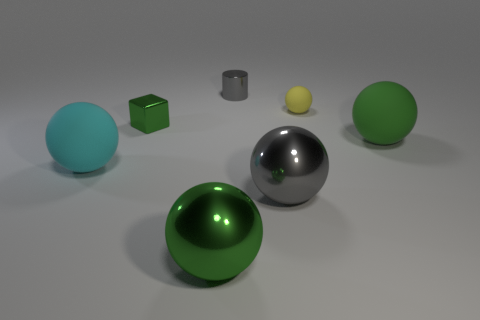Are there fewer cyan matte spheres that are behind the small green object than tiny green metal cubes that are behind the small gray cylinder?
Provide a short and direct response. No. What is the color of the tiny block?
Your response must be concise. Green. What number of metallic objects have the same color as the tiny cylinder?
Offer a very short reply. 1. Are there any gray shiny balls behind the green metal block?
Offer a very short reply. No. Is the number of metal objects that are behind the green matte thing the same as the number of cyan rubber balls in front of the yellow matte object?
Your response must be concise. No. Is the size of the gray shiny object that is in front of the small yellow thing the same as the gray metal object behind the tiny yellow matte sphere?
Provide a short and direct response. No. There is a small metal object right of the green thing that is behind the green ball behind the large cyan thing; what shape is it?
Provide a short and direct response. Cylinder. Is there any other thing that has the same material as the cube?
Provide a short and direct response. Yes. There is a yellow matte thing that is the same shape as the cyan matte object; what is its size?
Your answer should be very brief. Small. The rubber ball that is both in front of the yellow thing and on the right side of the cyan rubber sphere is what color?
Provide a short and direct response. Green. 